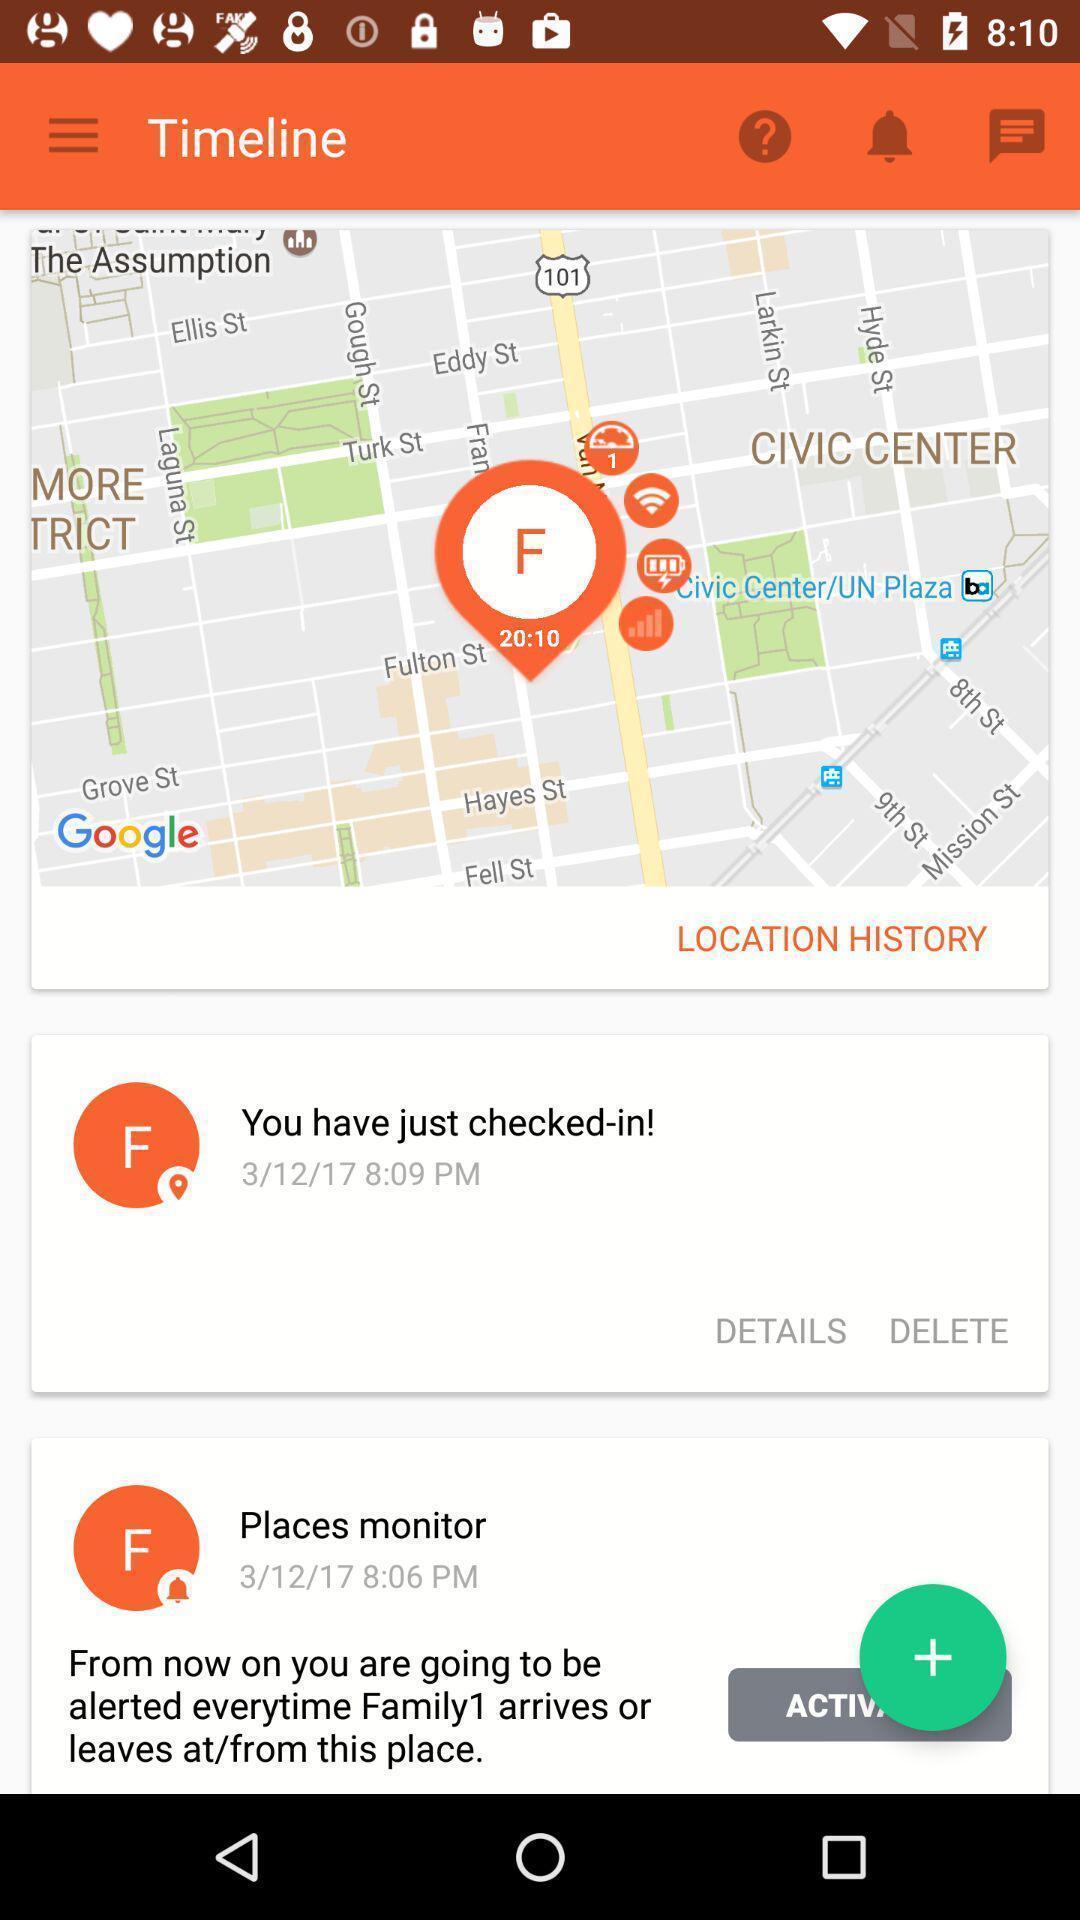What can you discern from this picture? Page of a navigation app. 